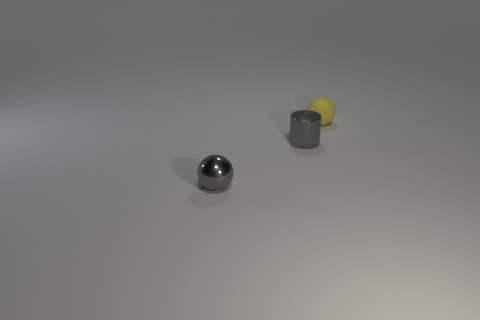Does the gray sphere have the same material as the thing behind the gray cylinder?
Provide a short and direct response. No. What is the size of the metal thing that is the same color as the tiny cylinder?
Ensure brevity in your answer.  Small. Are there any yellow spheres made of the same material as the tiny yellow thing?
Keep it short and to the point. No. How many objects are tiny gray things that are on the left side of the metal cylinder or balls that are on the right side of the tiny gray shiny ball?
Give a very brief answer. 2. There is a yellow object; does it have the same shape as the small object that is in front of the small gray cylinder?
Your response must be concise. Yes. What number of other things are there of the same shape as the tiny yellow matte object?
Your answer should be compact. 1. How many objects are brown cylinders or rubber objects?
Your answer should be very brief. 1. Do the metallic sphere and the cylinder have the same color?
Provide a short and direct response. Yes. Is there anything else that has the same size as the gray metal ball?
Provide a succinct answer. Yes. There is a tiny shiny thing behind the object that is to the left of the gray cylinder; what is its shape?
Offer a terse response. Cylinder. 